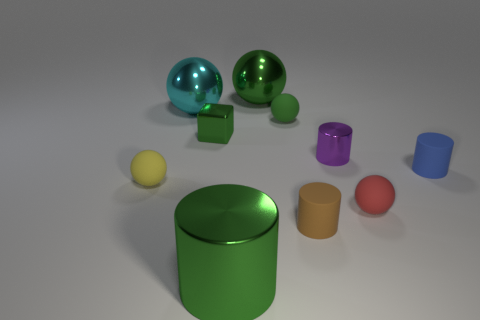Subtract all red cylinders. How many green spheres are left? 2 Subtract all cyan spheres. How many spheres are left? 4 Subtract all large cyan spheres. How many spheres are left? 4 Subtract all brown balls. Subtract all purple blocks. How many balls are left? 5 Subtract all purple metal cylinders. Subtract all cyan metallic objects. How many objects are left? 8 Add 8 tiny blue rubber cylinders. How many tiny blue rubber cylinders are left? 9 Add 6 yellow spheres. How many yellow spheres exist? 7 Subtract 1 green cylinders. How many objects are left? 9 Subtract all cylinders. How many objects are left? 6 